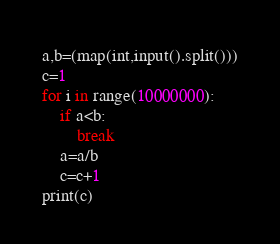<code> <loc_0><loc_0><loc_500><loc_500><_Python_>a,b=(map(int,input().split()))
c=1
for i in range(10000000):
    if a<b:
        break
    a=a/b
    c=c+1
print(c)</code> 